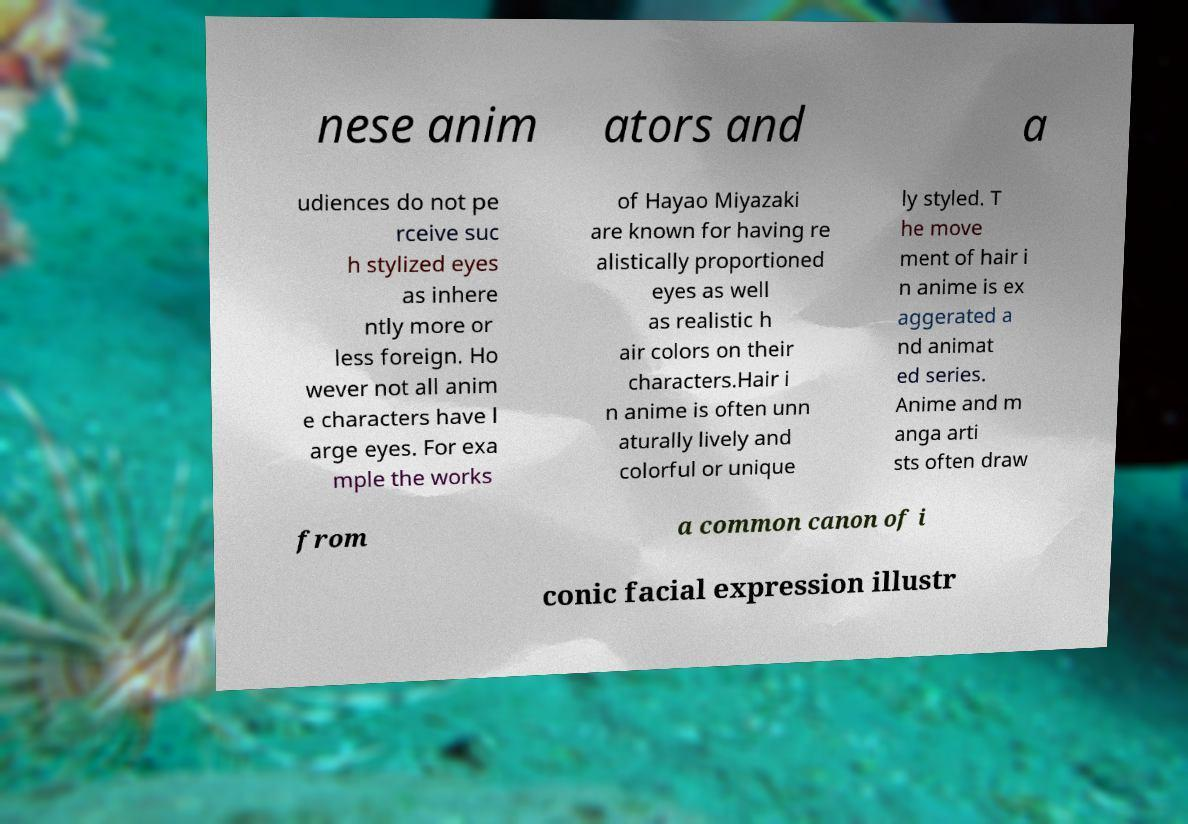I need the written content from this picture converted into text. Can you do that? nese anim ators and a udiences do not pe rceive suc h stylized eyes as inhere ntly more or less foreign. Ho wever not all anim e characters have l arge eyes. For exa mple the works of Hayao Miyazaki are known for having re alistically proportioned eyes as well as realistic h air colors on their characters.Hair i n anime is often unn aturally lively and colorful or unique ly styled. T he move ment of hair i n anime is ex aggerated a nd animat ed series. Anime and m anga arti sts often draw from a common canon of i conic facial expression illustr 